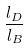Convert formula to latex. <formula><loc_0><loc_0><loc_500><loc_500>\frac { l _ { D } } { l _ { B } }</formula> 